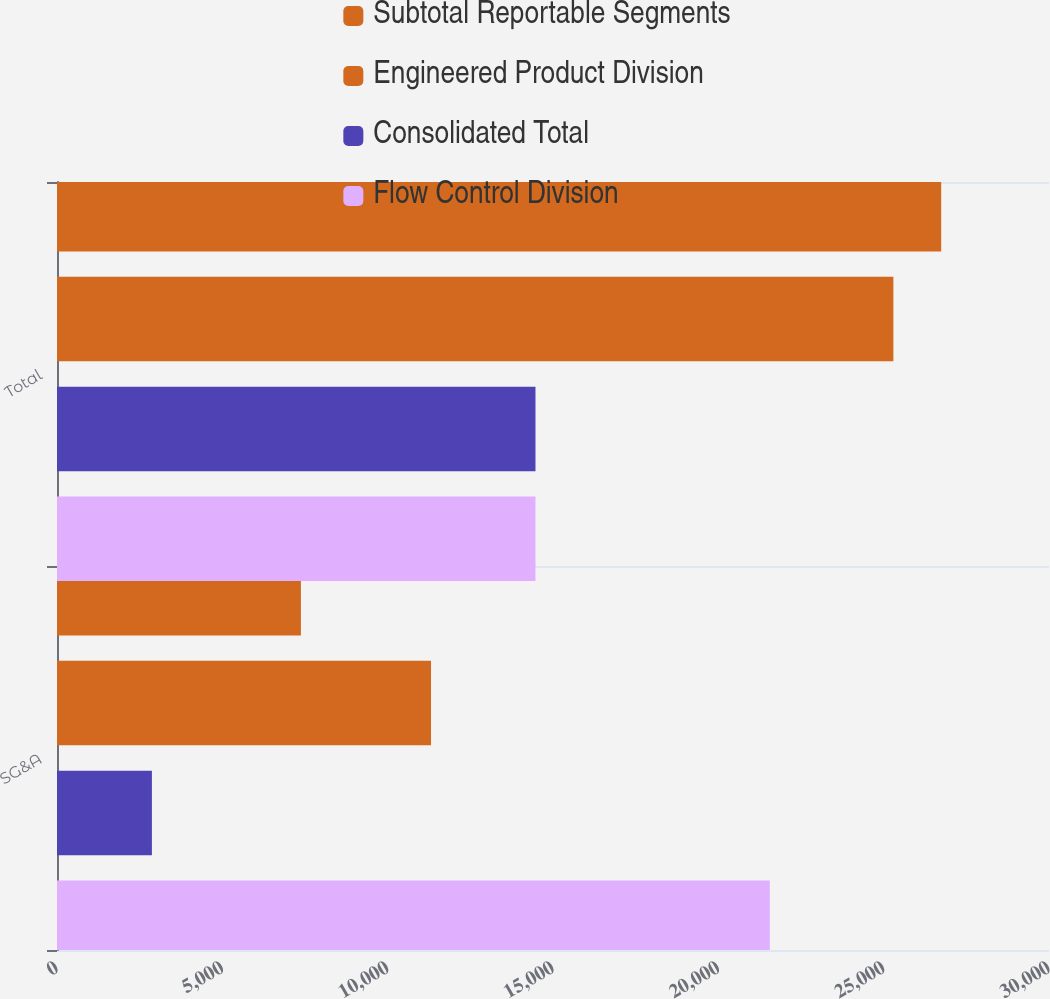<chart> <loc_0><loc_0><loc_500><loc_500><stacked_bar_chart><ecel><fcel>SG&A<fcel>Total<nl><fcel>Subtotal Reportable Segments<fcel>7376<fcel>26740<nl><fcel>Engineered Product Division<fcel>11311<fcel>25294<nl><fcel>Consolidated Total<fcel>2870<fcel>14470<nl><fcel>Flow Control Division<fcel>21557<fcel>14470<nl></chart> 